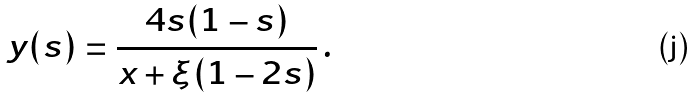Convert formula to latex. <formula><loc_0><loc_0><loc_500><loc_500>y ( s ) = \frac { 4 s ( 1 - s ) } { x + \xi ( 1 - 2 s ) } \, .</formula> 